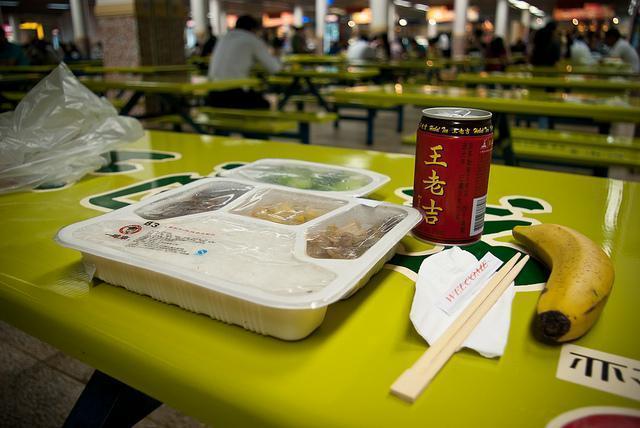How many desserts are in the picture?
Give a very brief answer. 1. How many dining tables are there?
Give a very brief answer. 3. 